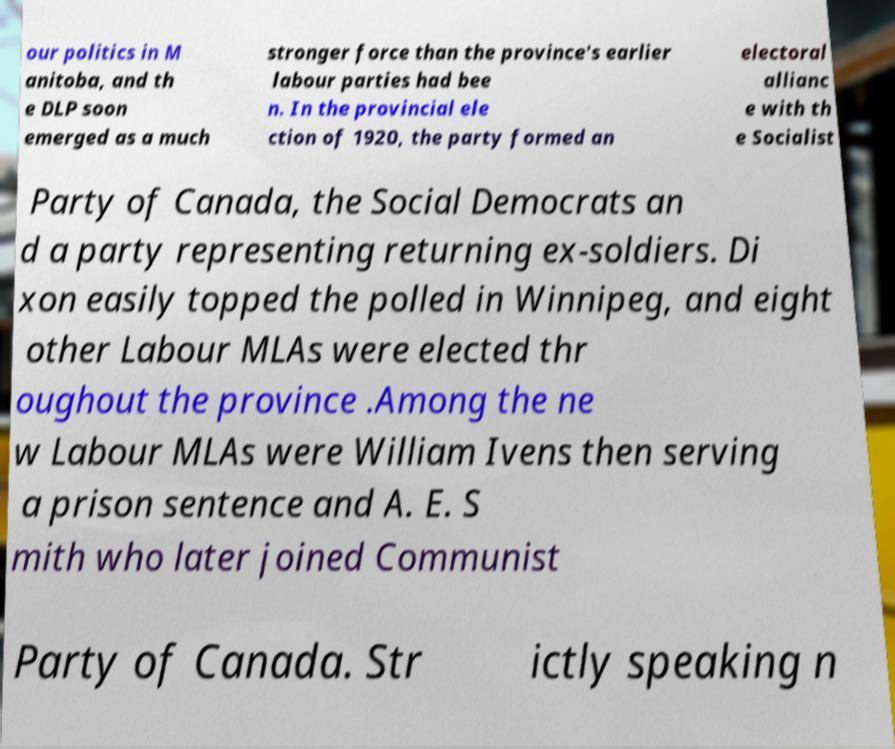There's text embedded in this image that I need extracted. Can you transcribe it verbatim? our politics in M anitoba, and th e DLP soon emerged as a much stronger force than the province's earlier labour parties had bee n. In the provincial ele ction of 1920, the party formed an electoral allianc e with th e Socialist Party of Canada, the Social Democrats an d a party representing returning ex-soldiers. Di xon easily topped the polled in Winnipeg, and eight other Labour MLAs were elected thr oughout the province .Among the ne w Labour MLAs were William Ivens then serving a prison sentence and A. E. S mith who later joined Communist Party of Canada. Str ictly speaking n 